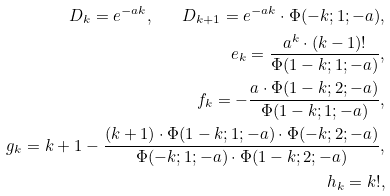Convert formula to latex. <formula><loc_0><loc_0><loc_500><loc_500>D _ { k } = e ^ { - a k } , \quad D _ { k + 1 } = e ^ { - a k } \cdot \Phi ( - k ; 1 ; - a ) , \\ e _ { k } = \frac { a ^ { k } \cdot ( k - 1 ) ! } { \Phi ( 1 - k ; 1 ; - a ) } , \\ f _ { k } = - \frac { a \cdot \Phi ( 1 - k ; 2 ; - a ) } { \Phi ( 1 - k ; 1 ; - a ) } , \\ g _ { k } = k + 1 - \frac { ( k + 1 ) \cdot \Phi ( 1 - k ; 1 ; - a ) \cdot \Phi ( - k ; 2 ; - a ) } { \Phi ( - k ; 1 ; - a ) \cdot \Phi ( 1 - k ; 2 ; - a ) } , \\ h _ { k } = k ! ,</formula> 